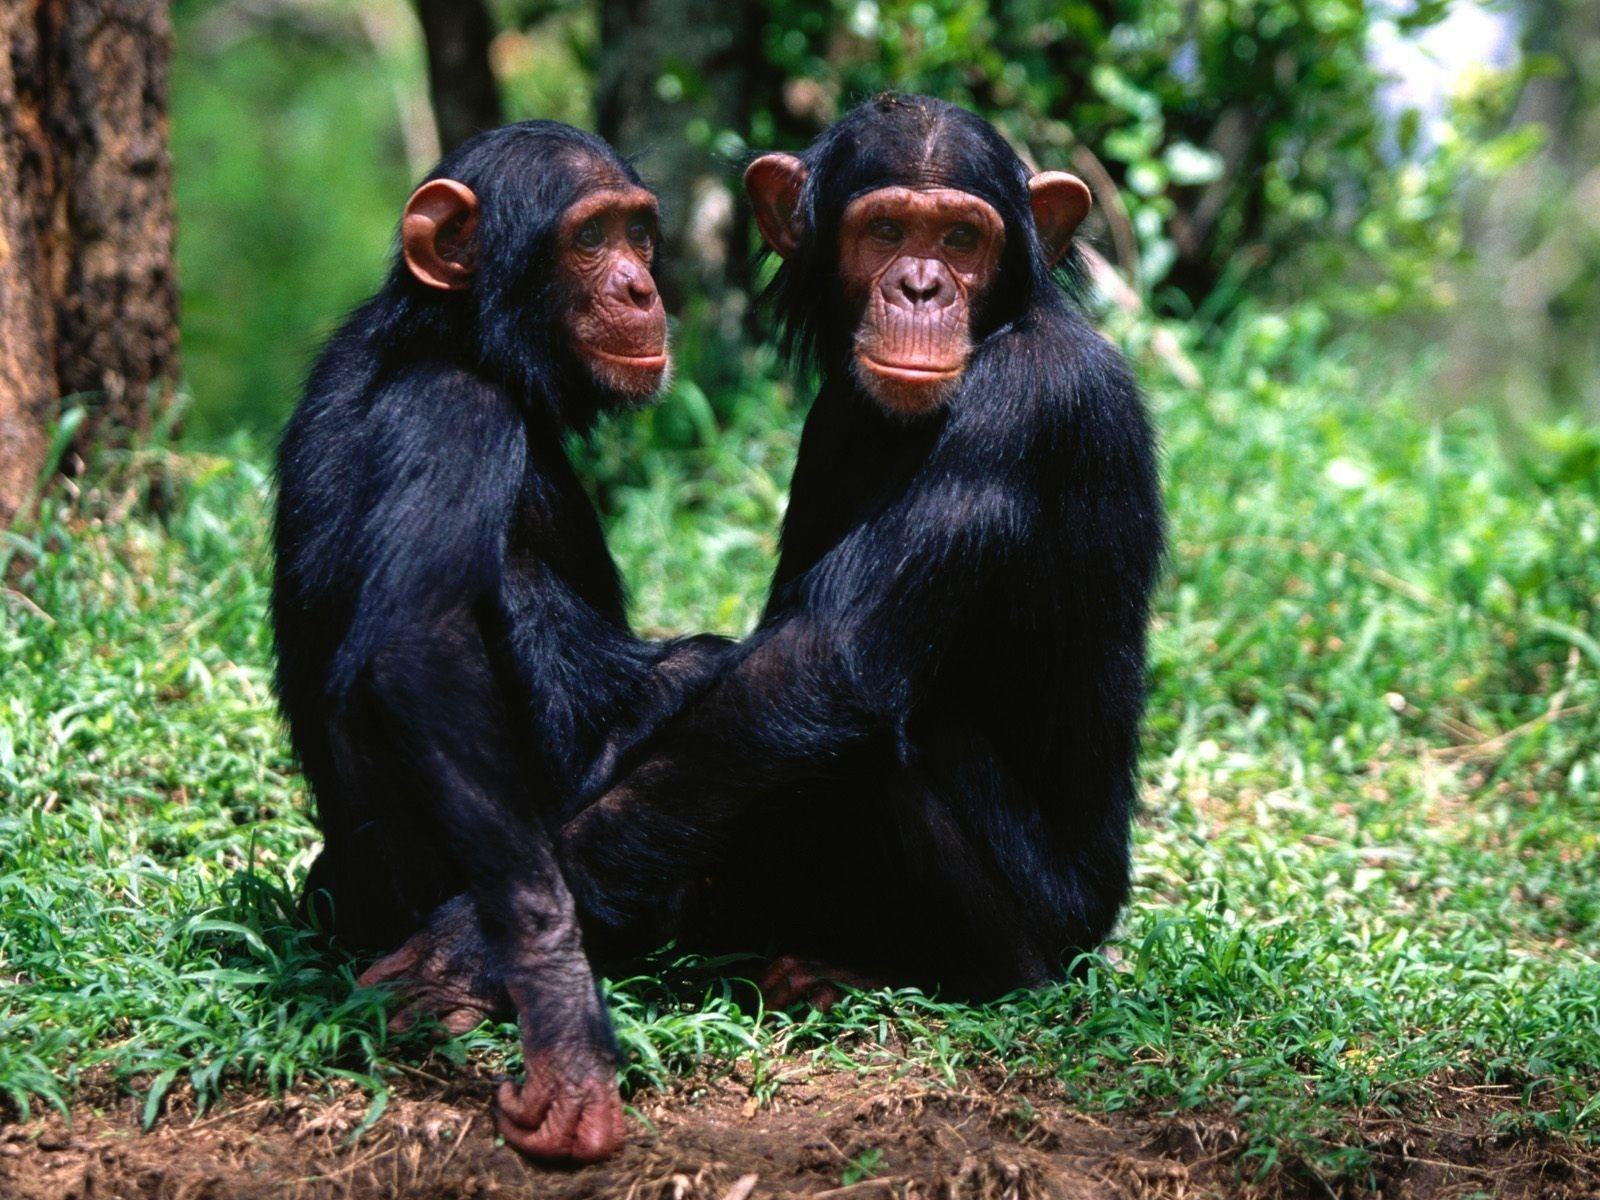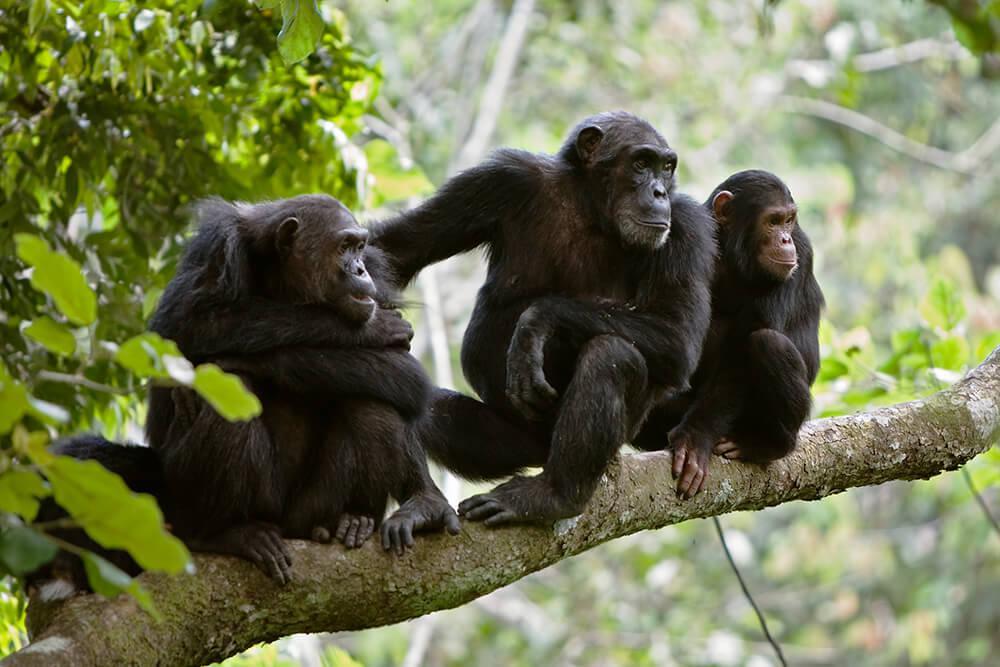The first image is the image on the left, the second image is the image on the right. Considering the images on both sides, is "There is exactly one animal in the image on the right." valid? Answer yes or no. No. The first image is the image on the left, the second image is the image on the right. Considering the images on both sides, is "One image shows two chimpanzees sitting in the grass together." valid? Answer yes or no. Yes. 